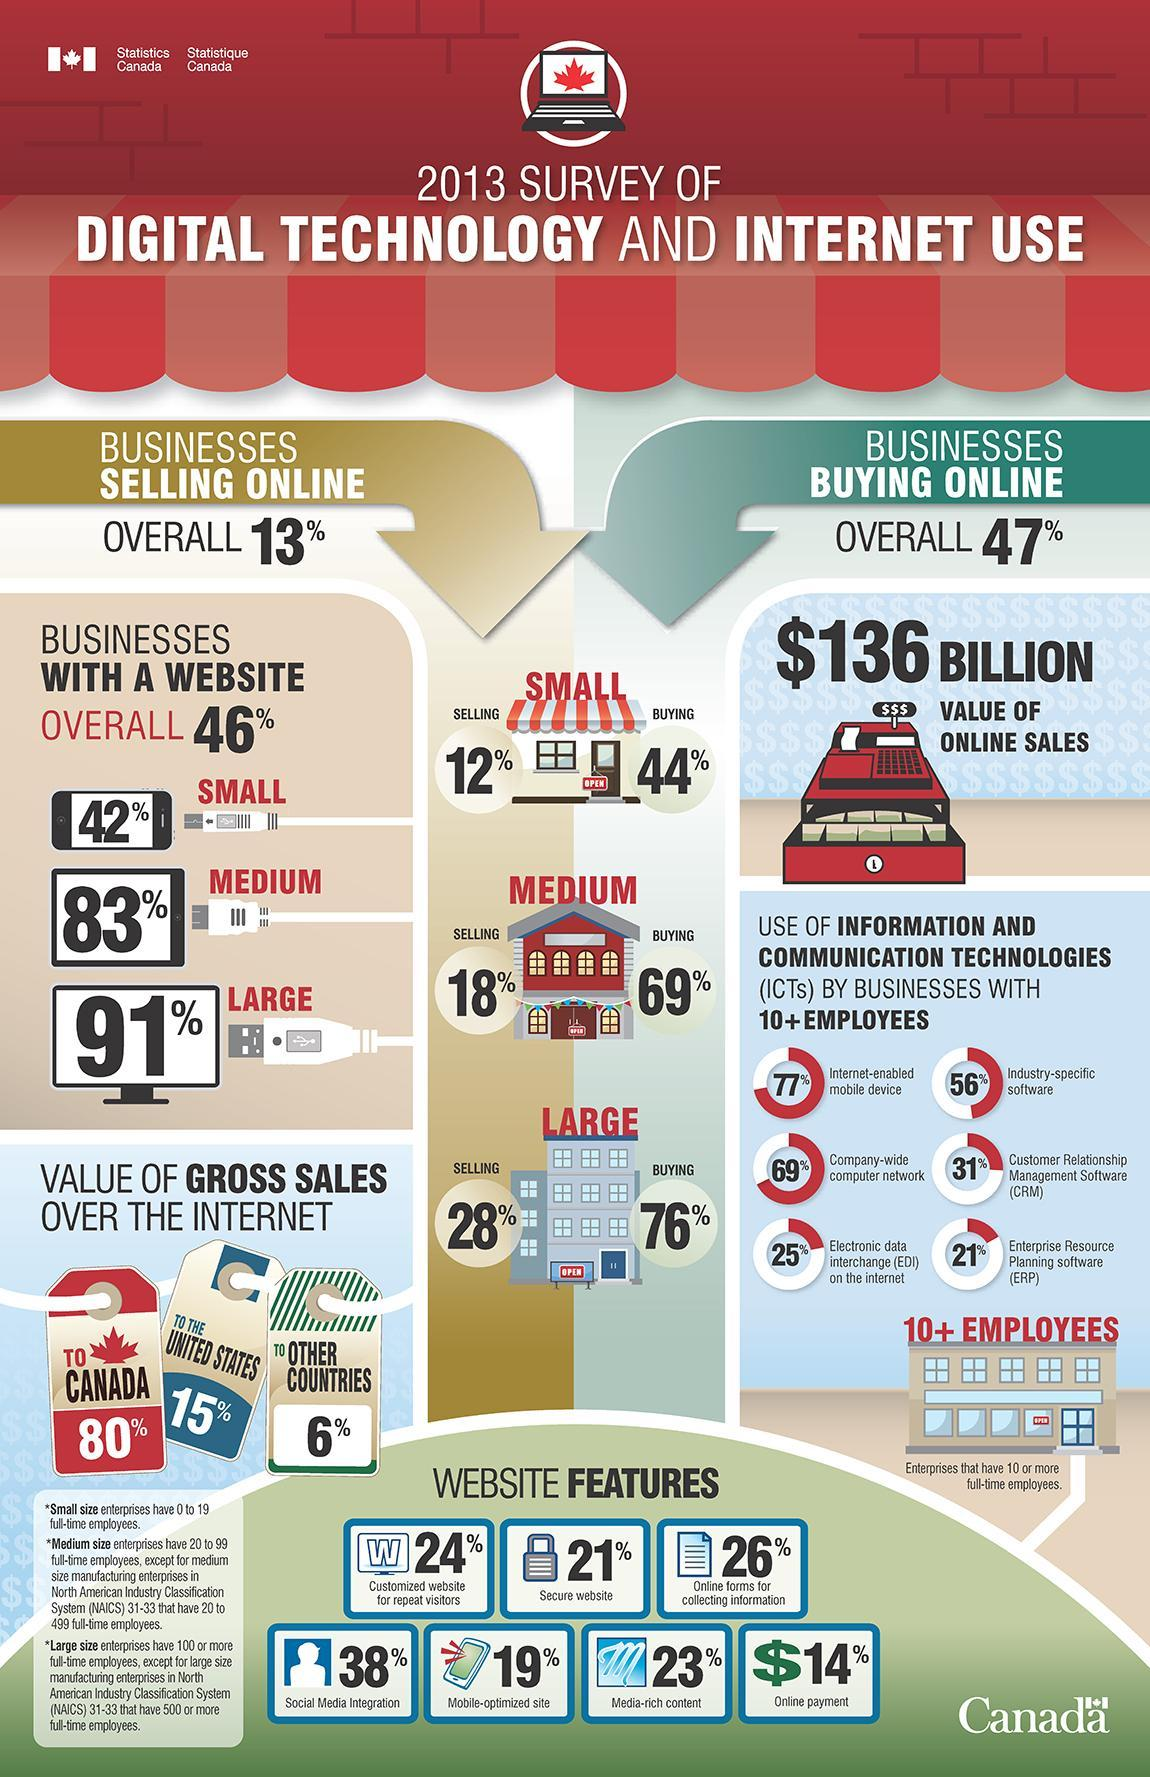What percentage of businesses with 10+ employees uses EDI on the internet in Canada according to 2013 survey?
Answer the question with a short phrase. 25% Which is the least used Information & Communication Technology by businesses with 10+ employees in Canada according to 2013 survey? Enterprise Resource Planning software (ERP) Which is the most used Information & Communication Technology by businesses with 10+ employees in Canada according to 2013 survey? Internet-enabled mobile device What is the percentage of businesses sales for medium size enterprises with a website in Canada in 2013 ? 83% What percentage of businesses with 10+ employees uses ERP software in Canada  in 2013 survey? 21% What is the percentage of businesses sales for small size enterprises with a website in Canada in 2013 ? 42% What percentage is the value of gross sales over the internet to the United States in 2013 survey? 15% What percentage is the value of gross sales over the internet to Canada in 2013 survey? 80% What is the percentage of businesses sales for large size enterprises with a website in Canada in 2013 ? 91% 